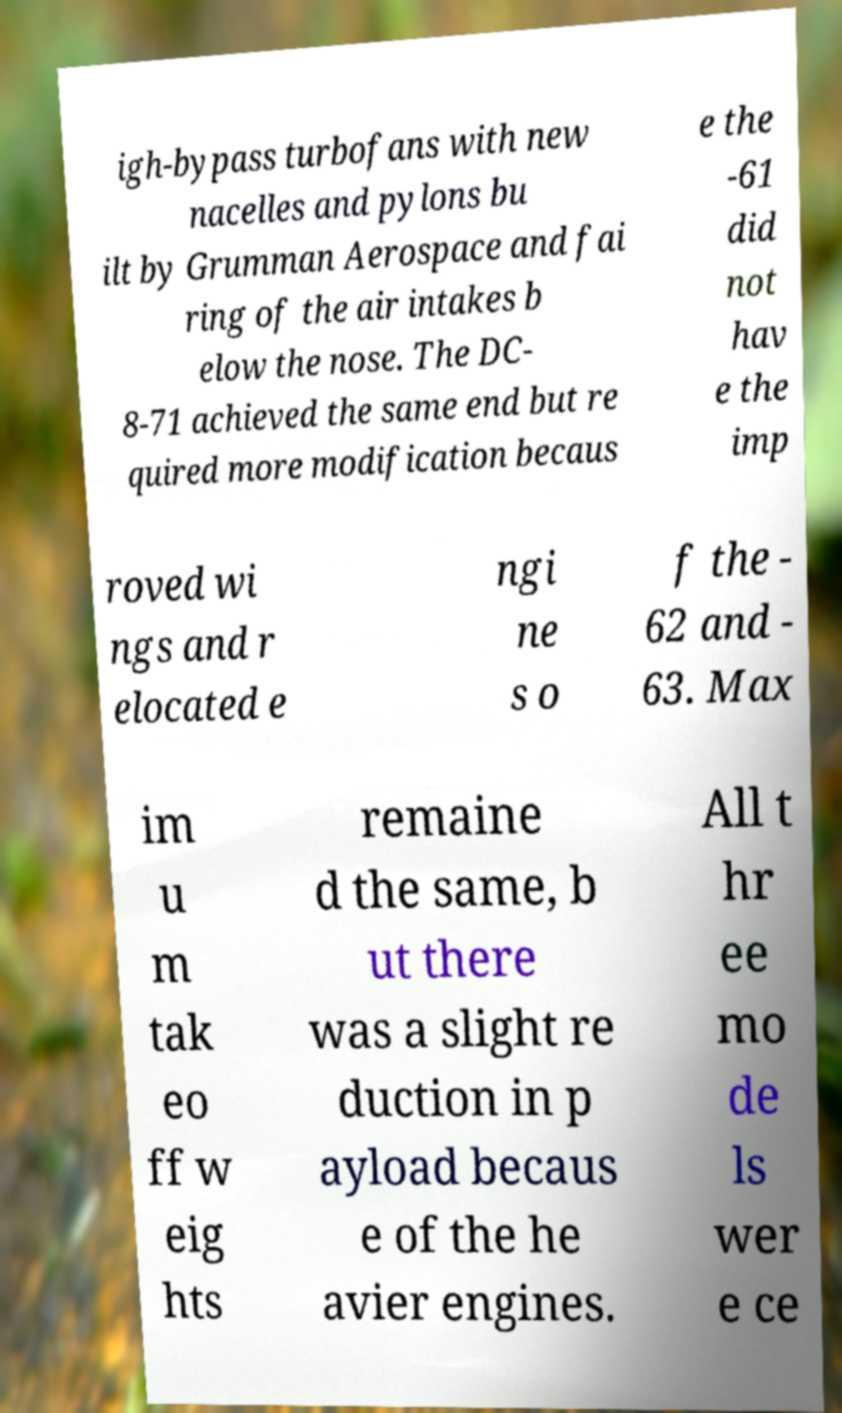Please read and relay the text visible in this image. What does it say? igh-bypass turbofans with new nacelles and pylons bu ilt by Grumman Aerospace and fai ring of the air intakes b elow the nose. The DC- 8-71 achieved the same end but re quired more modification becaus e the -61 did not hav e the imp roved wi ngs and r elocated e ngi ne s o f the - 62 and - 63. Max im u m tak eo ff w eig hts remaine d the same, b ut there was a slight re duction in p ayload becaus e of the he avier engines. All t hr ee mo de ls wer e ce 